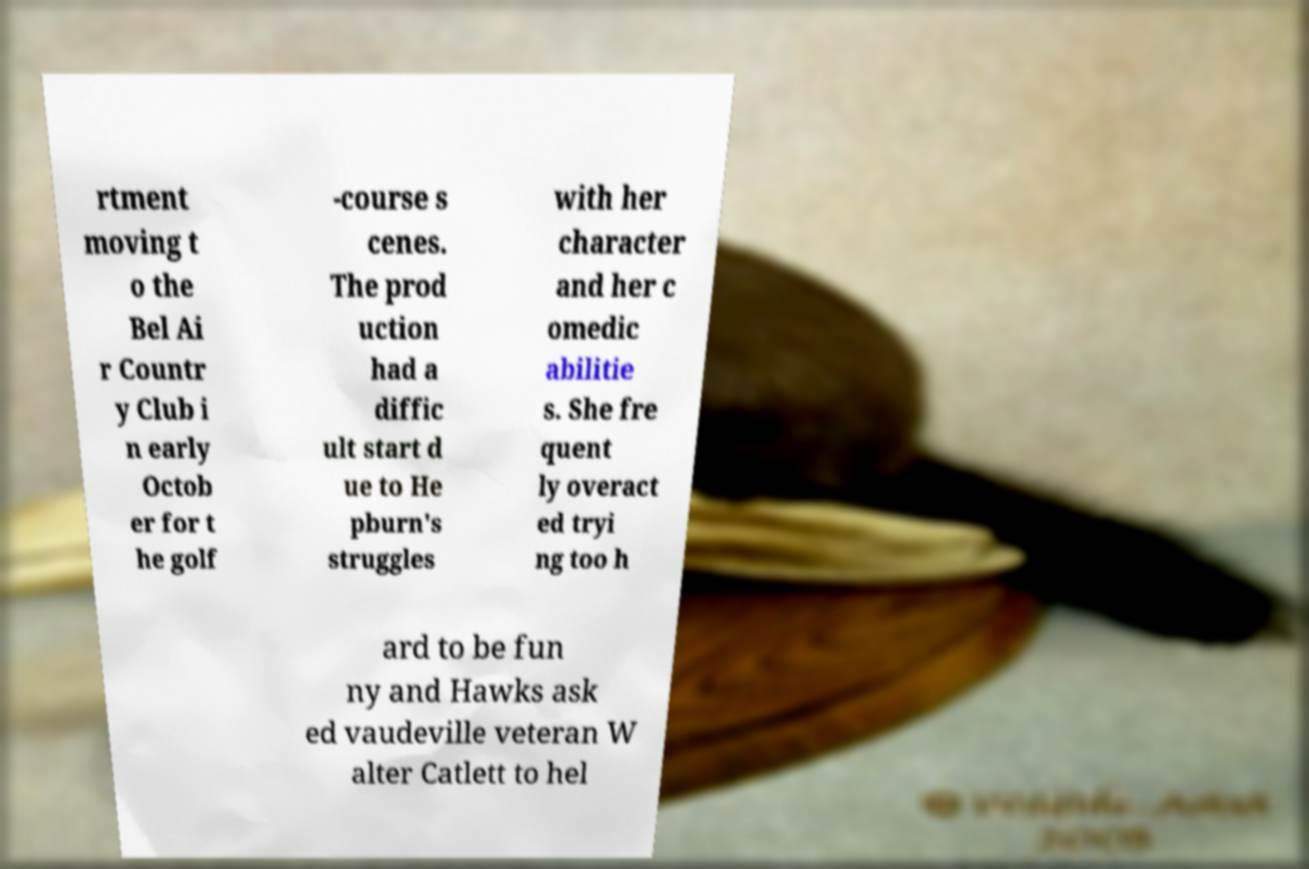Can you read and provide the text displayed in the image?This photo seems to have some interesting text. Can you extract and type it out for me? rtment moving t o the Bel Ai r Countr y Club i n early Octob er for t he golf -course s cenes. The prod uction had a diffic ult start d ue to He pburn's struggles with her character and her c omedic abilitie s. She fre quent ly overact ed tryi ng too h ard to be fun ny and Hawks ask ed vaudeville veteran W alter Catlett to hel 